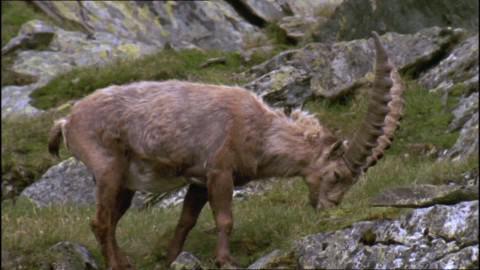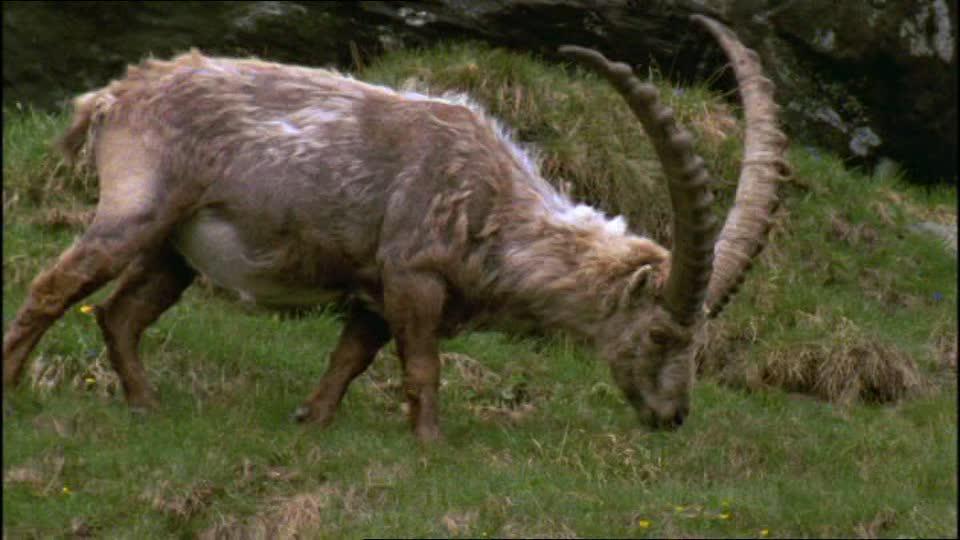The first image is the image on the left, the second image is the image on the right. For the images displayed, is the sentence "The right image shows a ram next to rocks." factually correct? Answer yes or no. No. 